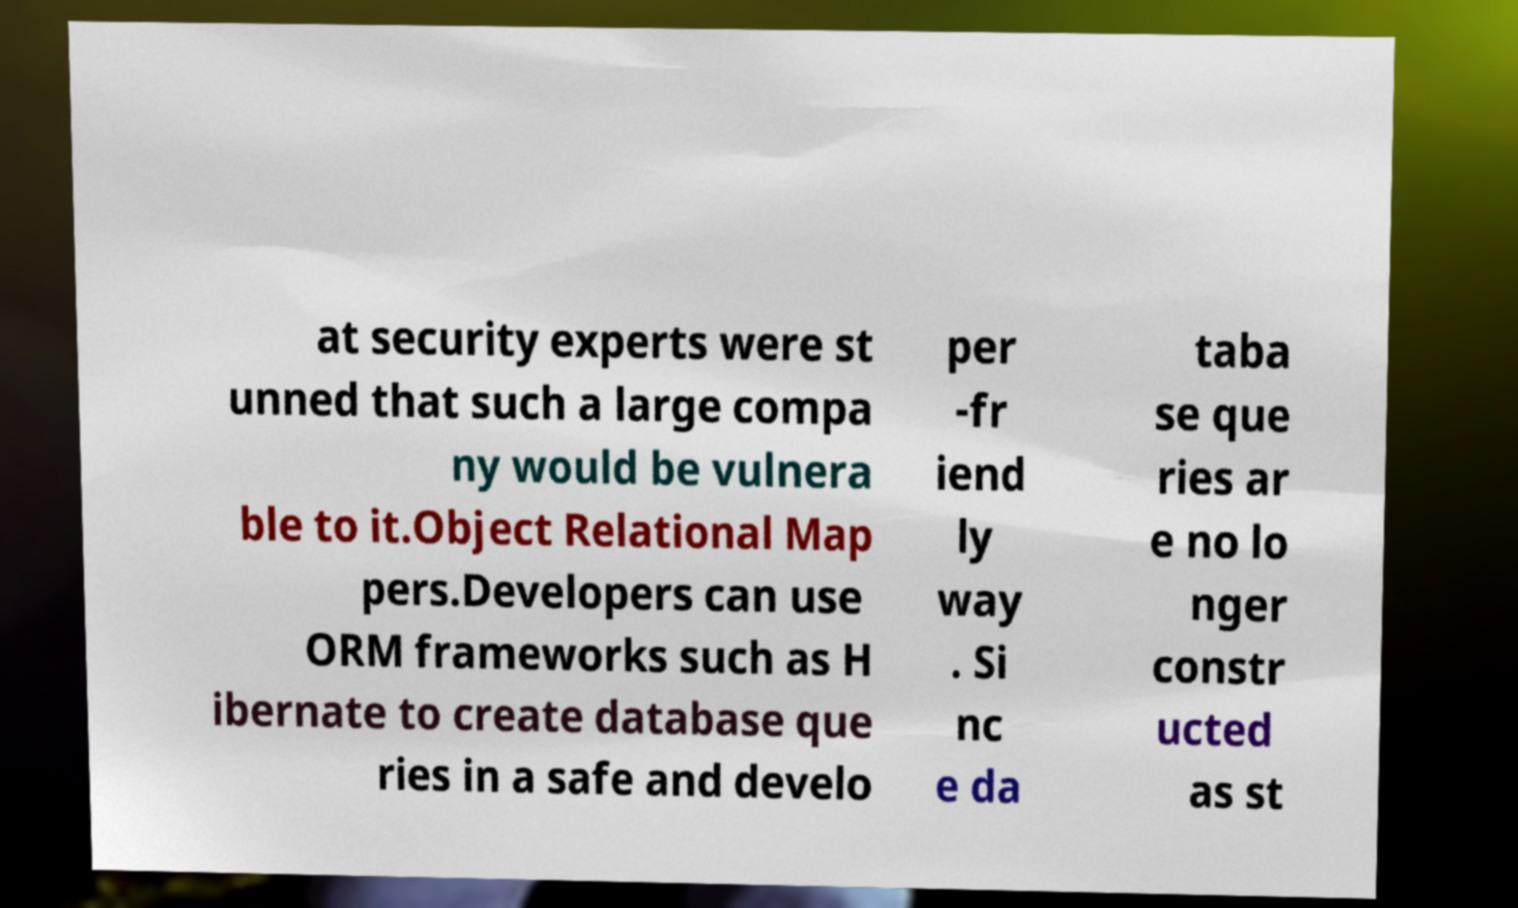Could you assist in decoding the text presented in this image and type it out clearly? at security experts were st unned that such a large compa ny would be vulnera ble to it.Object Relational Map pers.Developers can use ORM frameworks such as H ibernate to create database que ries in a safe and develo per -fr iend ly way . Si nc e da taba se que ries ar e no lo nger constr ucted as st 